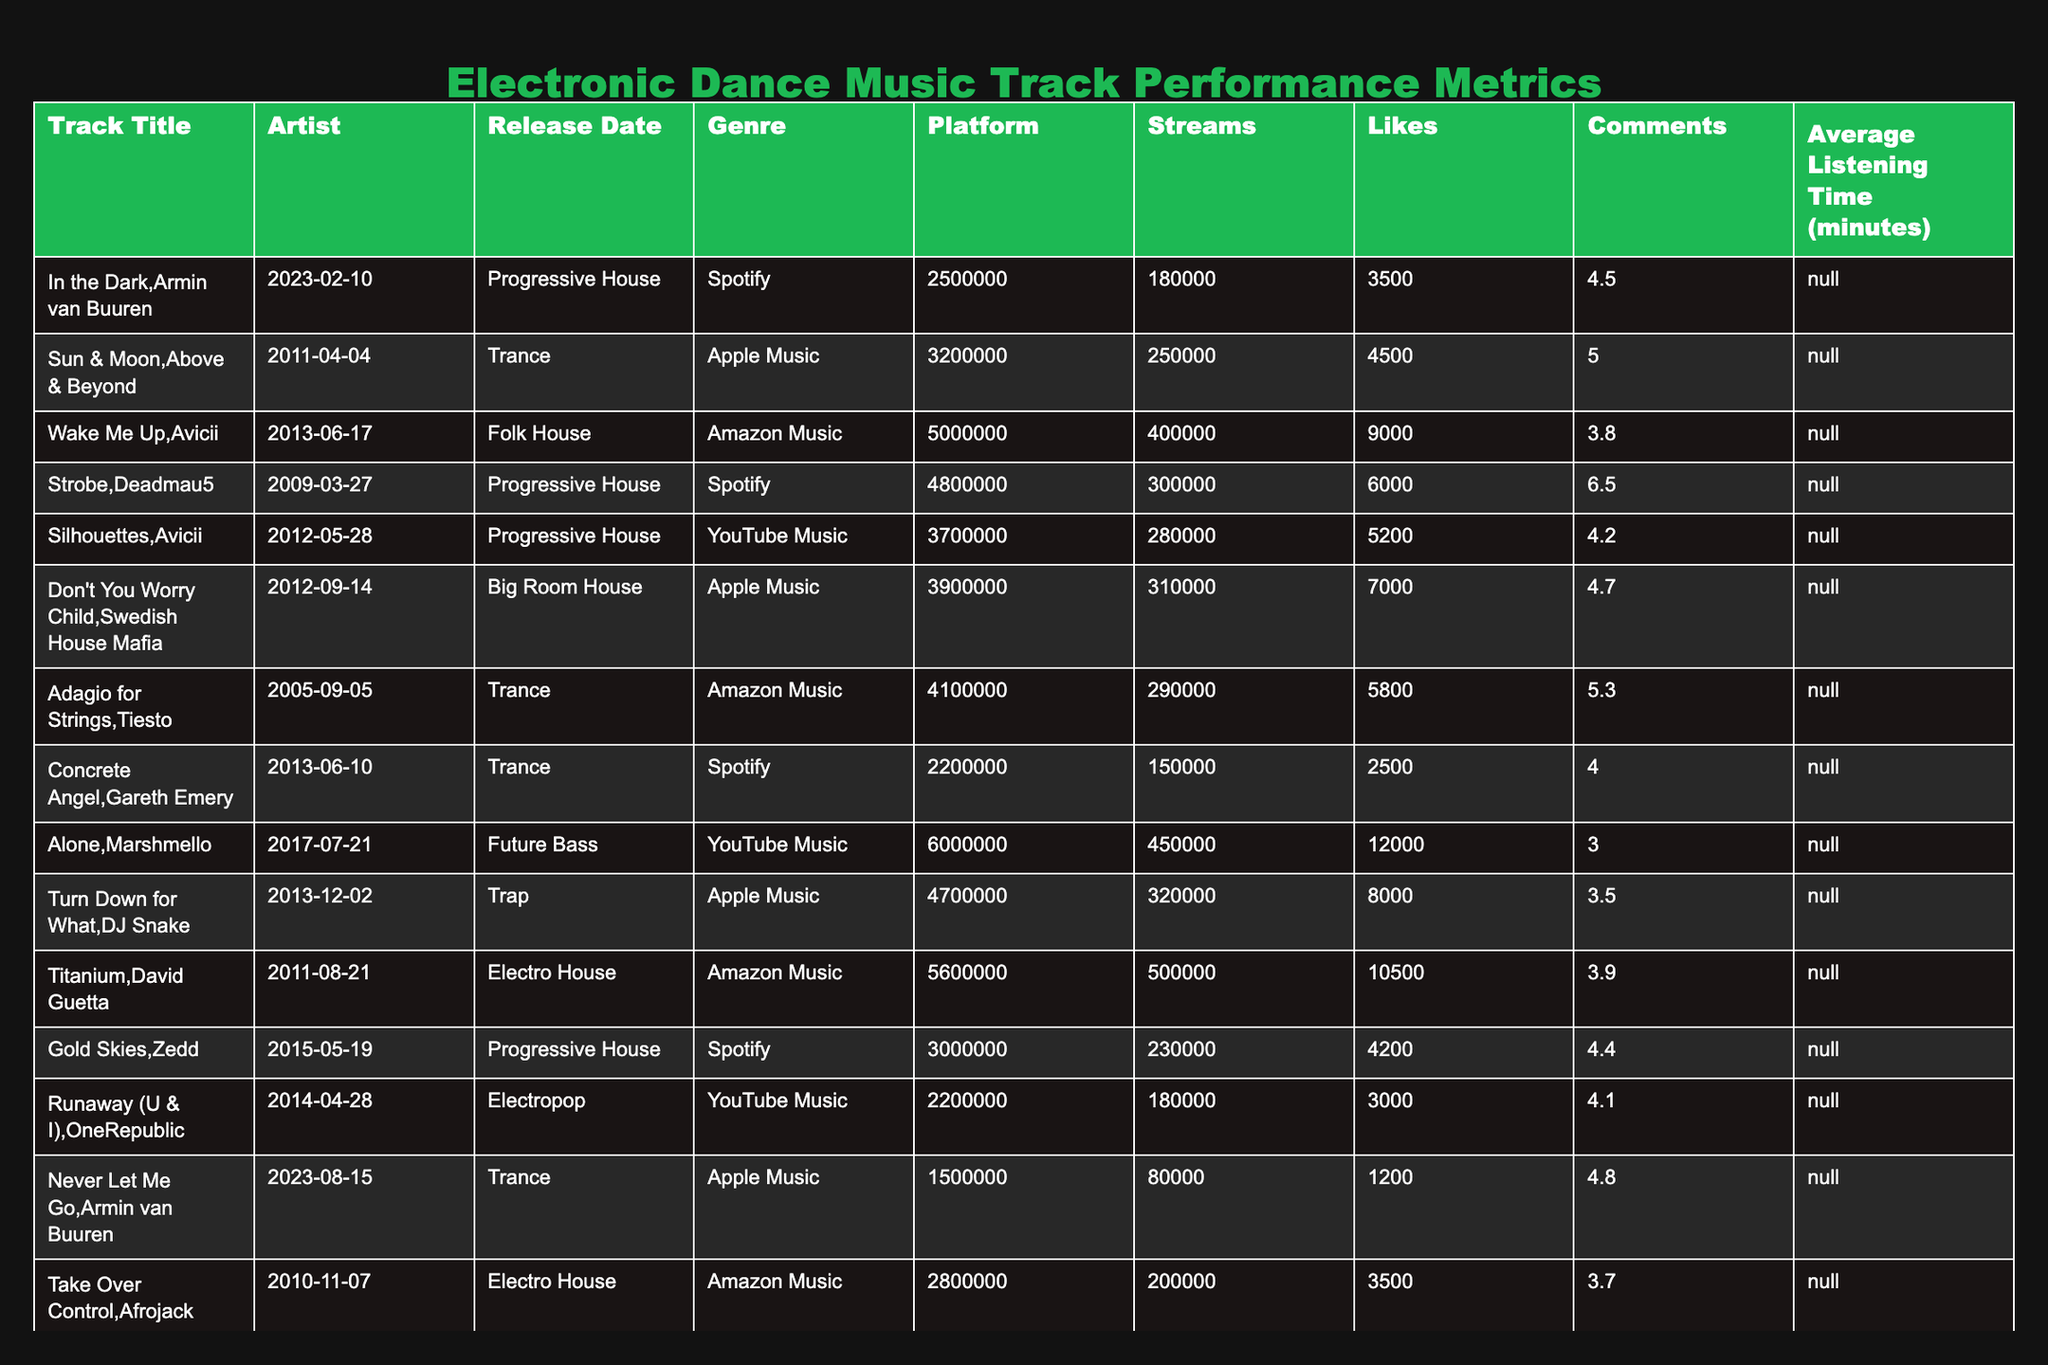What is the total number of streams for all tracks? To find the total number of streams, we add together the streams of each track: 2500000 + 3200000 + 5000000 + 4800000 + 3700000 + 3900000 + 4100000 + 2200000 + 6000000 + 4700000 + 5600000 + 3000000 + 2200000 + 1500000 + 2800000 + 3500000 + 4000000 =  44,300,000
Answer: 44300000 Which track has the highest number of likes? By looking at the likes column, the highest value is for "Alone" with 450000 likes. The values for other tracks are lower than this.
Answer: Alone What is the average listening time of tracks in the Progressive House genre? The listening times for Progressive House tracks are 4.5, 6.5, 4.4, and 5.2 minutes. There are 4 tracks, so we sum the times (4.5 + 6.5 + 4.4 + 5.2) = 20.6. Then divide by 4 to find the average. 20.6 / 4 = 5.15
Answer: 5.15 Does "Titanium" have more streams than "Wake Me Up"? "Titanium" has 5600000 streams and "Wake Me Up" has 5000000 streams. Since 5600000 is greater than 5000000, the statement is true.
Answer: Yes Which genre has the lowest average likes across its tracks? We calculate the average likes for each genre:
- Progressive House: (180000 + 300000 + 230000 + 360000) / 4 = 267500
- Trance: (250000 + 290000 + 80000) / 3 = 172500
- Electro House: (500000 + 200000) / 2 = 350000
- Future Bass: (450000) / 1 = 450000
- Big Room House: (310000) / 1 = 310000
- Folk House: (400000) / 1 = 400000
- Dubstep: (280000) / 1 = 280000
- Trap: (320000) / 1 = 320000  
From these calculations, Trance has the lowest average likes.
Answer: Trance Which artist has the most tracks listed in the table? We count the occurrences of each artist: Armin van Buuren (2), Above & Beyond (1), Avicii (2), Deadmau5 (1), Swedish House Mafia (1), Tiesto (1), Gareth Emery (1), Marshmello (1), DJ Snake (1), David Guetta (1), Zedd (2), OneRepublic (1), Afrojack (1), and Sebastian Ingrosso (1). The maximum is 2 tracks, shared by Armin van Buuren, Avicii, and Zedd.
Answer: Armin van Buuren, Avicii, and Zedd What is the percentage of likes for "Running Alone"? The track "Never Let Me Go" by Armin van Buuren has 1500000 streams and 80000 likes. To find the percentage of likes, we use the formula (likes/streams) * 100. So, (80000 / 1500000) * 100 = 5.33%.
Answer: 5.33% Which track has the longest average listening time? By reviewing all listening times, "Strobe" has the highest average listening time of 6.5 minutes. The other tracks have times that are less than this.
Answer: Strobe What is the difference in streams between the highest and lowest performing tracks? The highest performing track in terms of streams is "Alone" with 6000000, and the lowest is "Never Let Me Go" with 1500000. The difference is 6000000 - 1500000 = 4500000 streams.
Answer: 4500000 Does "In the Dark" have more comments than "Don't You Worry Child"? "In the Dark" has 3500 comments, while "Don't You Worry Child" has 7000 comments. Since 3500 is less than 7000, the answer is no.
Answer: No 